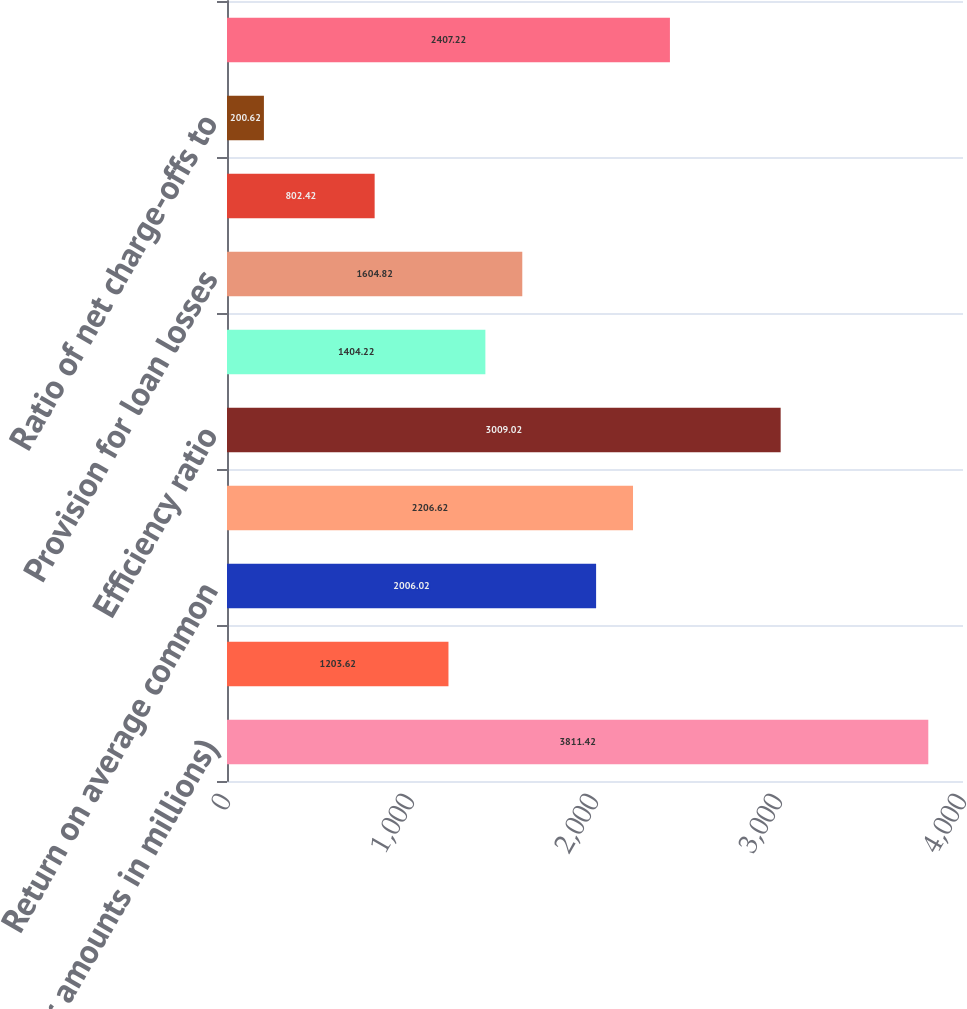Convert chart. <chart><loc_0><loc_0><loc_500><loc_500><bar_chart><fcel>(Dollar amounts in millions)<fcel>Return on average assets<fcel>Return on average common<fcel>Tangible return on average<fcel>Efficiency ratio<fcel>Net interest margin<fcel>Provision for loan losses<fcel>Net loan and lease charge-offs<fcel>Ratio of net charge-offs to<fcel>Allowance for loan losses<nl><fcel>3811.42<fcel>1203.62<fcel>2006.02<fcel>2206.62<fcel>3009.02<fcel>1404.22<fcel>1604.82<fcel>802.42<fcel>200.62<fcel>2407.22<nl></chart> 